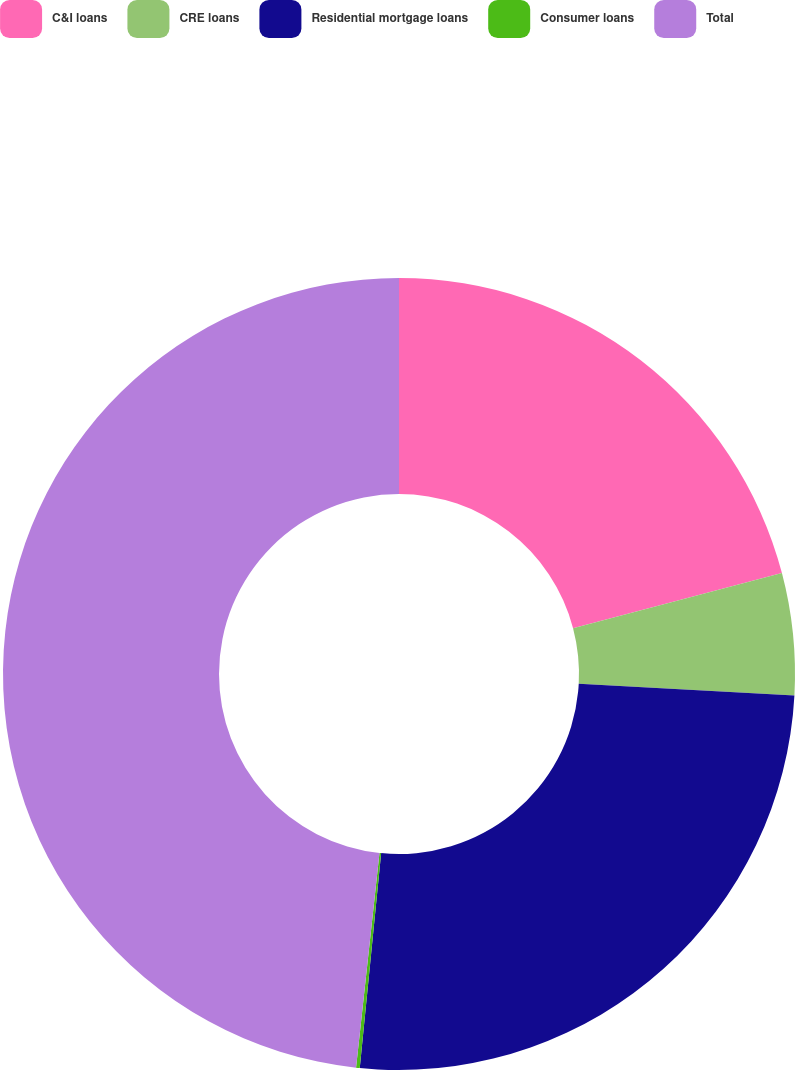Convert chart to OTSL. <chart><loc_0><loc_0><loc_500><loc_500><pie_chart><fcel>C&I loans<fcel>CRE loans<fcel>Residential mortgage loans<fcel>Consumer loans<fcel>Total<nl><fcel>20.9%<fcel>4.96%<fcel>25.72%<fcel>0.15%<fcel>48.27%<nl></chart> 